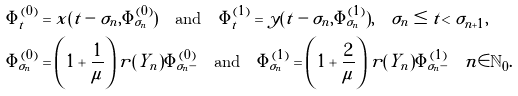Convert formula to latex. <formula><loc_0><loc_0><loc_500><loc_500>& \tilde { \Phi } ^ { ( 0 ) } _ { t } = x ( t - \sigma _ { n } , \tilde { \Phi } ^ { ( 0 ) } _ { \sigma _ { n } } ) \quad \text {and} \quad \tilde { \Phi } ^ { ( 1 ) } _ { t } = y ( t - \sigma _ { n } , \tilde { \Phi } ^ { ( 1 ) } _ { \sigma _ { n } } ) , \quad \sigma _ { n } \leq t < \sigma _ { n + 1 } , \\ & \tilde { \Phi } ^ { ( 0 ) } _ { \sigma _ { n } } = \left ( 1 + \frac { 1 } { \mu } \right ) r ( Y _ { n } ) \tilde { \Phi } ^ { ( 0 ) } _ { \sigma _ { n } - } \quad \text {and} \quad \tilde { \Phi } ^ { ( 1 ) } _ { \sigma _ { n } } = \left ( 1 + \frac { 2 } { \mu } \right ) r ( Y _ { n } ) \tilde { \Phi } ^ { ( 1 ) } _ { \sigma _ { n } - } \quad n \in \mathbb { N } _ { 0 } .</formula> 